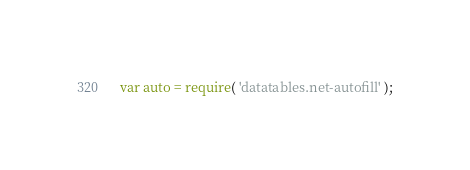<code> <loc_0><loc_0><loc_500><loc_500><_JavaScript_>var auto = require( 'datatables.net-autofill' );</code> 